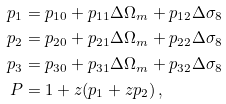Convert formula to latex. <formula><loc_0><loc_0><loc_500><loc_500>p _ { 1 } & = p _ { 1 0 } + p _ { 1 1 } \Delta \Omega _ { m } + p _ { 1 2 } \Delta \sigma _ { 8 } \\ p _ { 2 } & = p _ { 2 0 } + p _ { 2 1 } \Delta \Omega _ { m } + p _ { 2 2 } \Delta \sigma _ { 8 } \\ p _ { 3 } & = p _ { 3 0 } + p _ { 3 1 } \Delta \Omega _ { m } + p _ { 3 2 } \Delta \sigma _ { 8 } \\ P & = 1 + z ( p _ { 1 } + z p _ { 2 } ) \, ,</formula> 